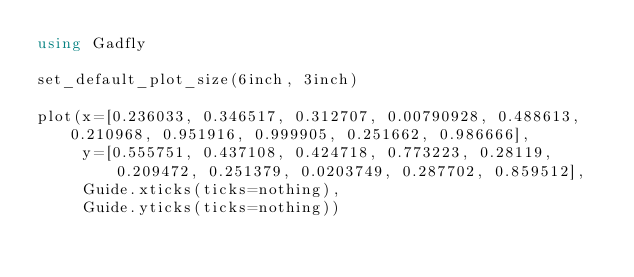<code> <loc_0><loc_0><loc_500><loc_500><_Julia_>using Gadfly

set_default_plot_size(6inch, 3inch)

plot(x=[0.236033, 0.346517, 0.312707, 0.00790928, 0.488613, 0.210968, 0.951916, 0.999905, 0.251662, 0.986666],
     y=[0.555751, 0.437108, 0.424718, 0.773223, 0.28119, 0.209472, 0.251379, 0.0203749, 0.287702, 0.859512],
     Guide.xticks(ticks=nothing),
     Guide.yticks(ticks=nothing))
</code> 